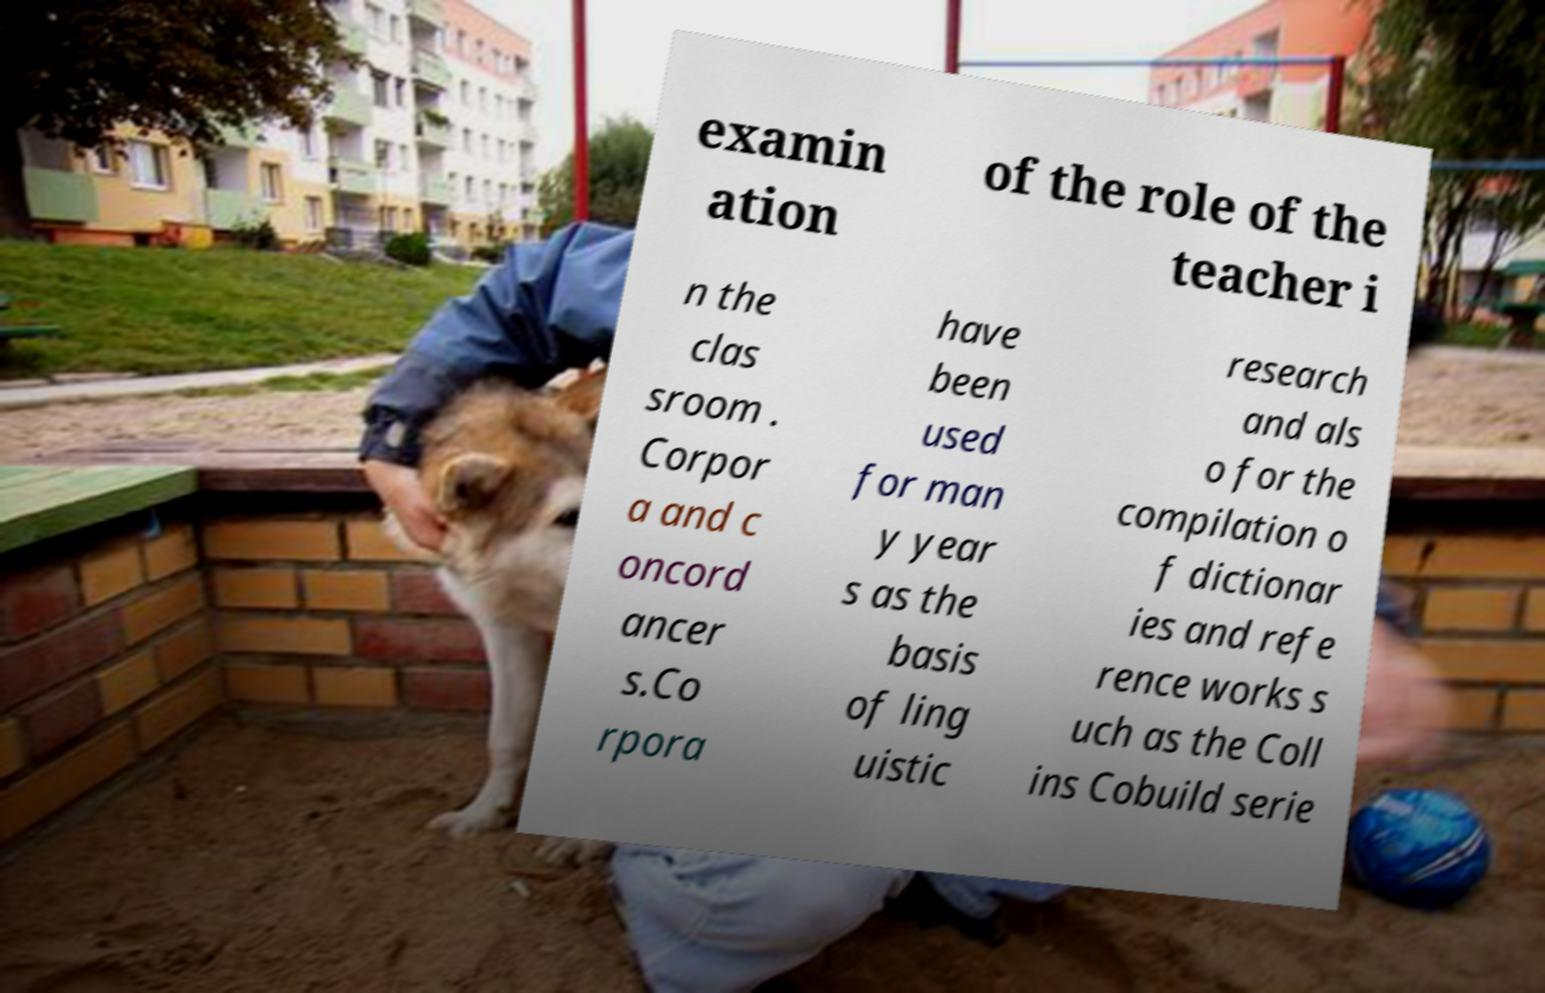Could you assist in decoding the text presented in this image and type it out clearly? examin ation of the role of the teacher i n the clas sroom . Corpor a and c oncord ancer s.Co rpora have been used for man y year s as the basis of ling uistic research and als o for the compilation o f dictionar ies and refe rence works s uch as the Coll ins Cobuild serie 